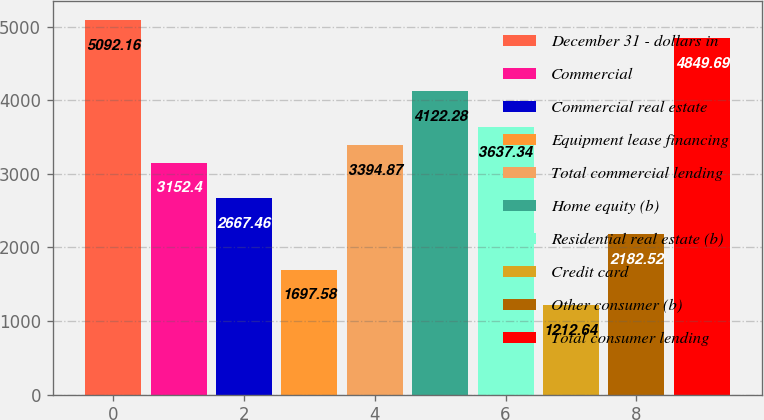<chart> <loc_0><loc_0><loc_500><loc_500><bar_chart><fcel>December 31 - dollars in<fcel>Commercial<fcel>Commercial real estate<fcel>Equipment lease financing<fcel>Total commercial lending<fcel>Home equity (b)<fcel>Residential real estate (b)<fcel>Credit card<fcel>Other consumer (b)<fcel>Total consumer lending<nl><fcel>5092.16<fcel>3152.4<fcel>2667.46<fcel>1697.58<fcel>3394.87<fcel>4122.28<fcel>3637.34<fcel>1212.64<fcel>2182.52<fcel>4849.69<nl></chart> 